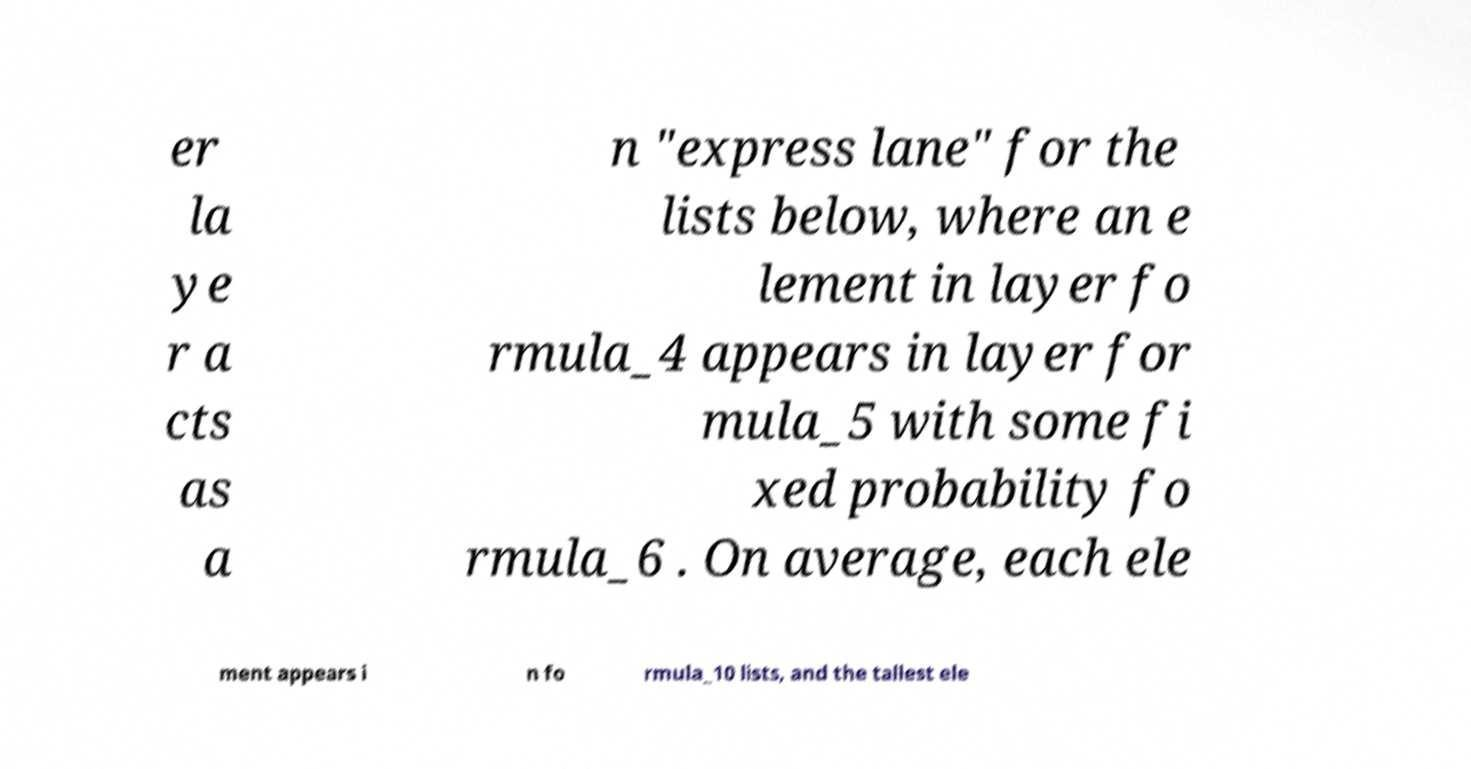Could you extract and type out the text from this image? er la ye r a cts as a n "express lane" for the lists below, where an e lement in layer fo rmula_4 appears in layer for mula_5 with some fi xed probability fo rmula_6 . On average, each ele ment appears i n fo rmula_10 lists, and the tallest ele 